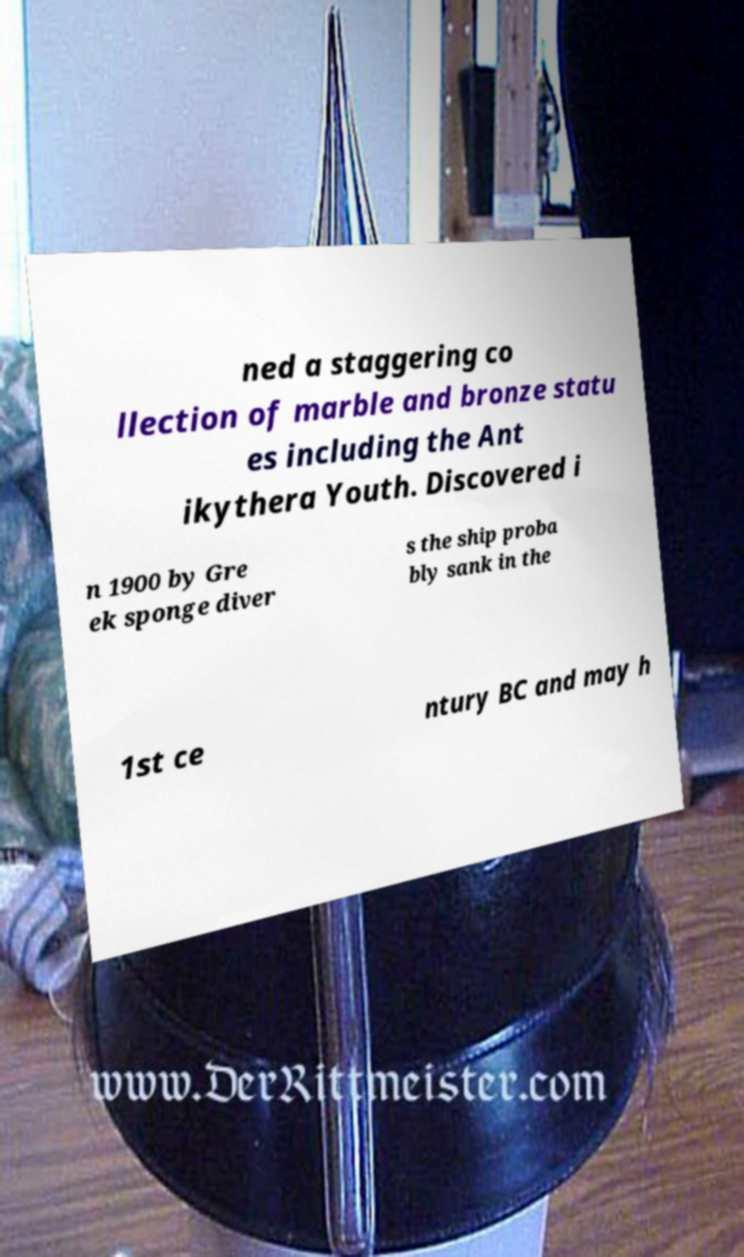Please read and relay the text visible in this image. What does it say? ned a staggering co llection of marble and bronze statu es including the Ant ikythera Youth. Discovered i n 1900 by Gre ek sponge diver s the ship proba bly sank in the 1st ce ntury BC and may h 